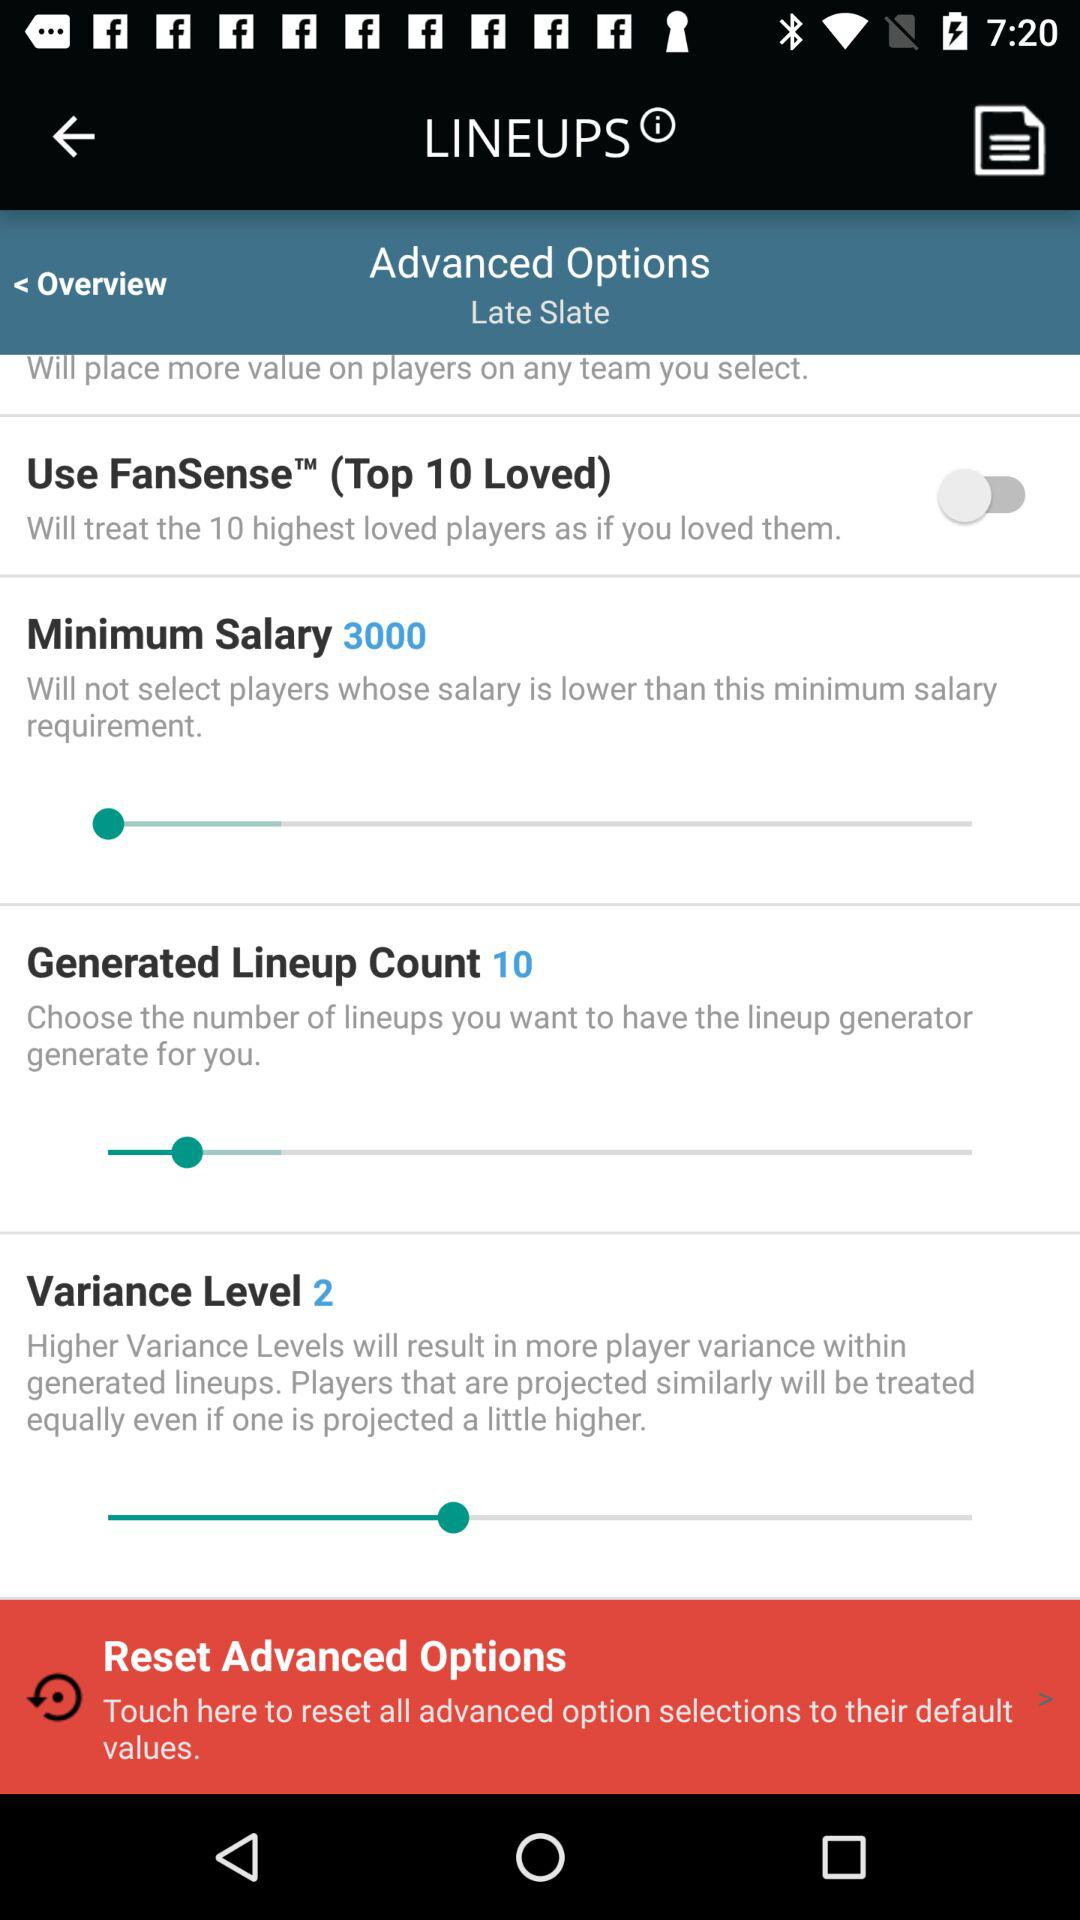What is the selected minimum salary? The selected minimum salary is 3,000. 